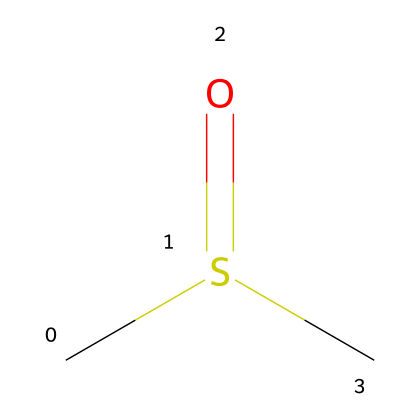What is the name of this chemical? The SMILES representation (CS(=O)C) indicates that the chemical has a sulfur atom and is a sulfoxide. Therefore, the correct name is dimethyl sulfoxide.
Answer: dimethyl sulfoxide How many carbon atoms are in dimethyl sulfoxide (DMSO)? Analyzing the SMILES code, there are two carbon atoms represented by the "C" symbols, which show the methyl groups attached to the sulfur.
Answer: 2 What type of functional group is present in dimethyl sulfoxide? The "=O" part of the structure indicates a carbonyl group bonded to sulfur, classifying it as a sulfoxide functional group.
Answer: sulfoxide What is the total number of atoms in dimethyl sulfoxide? Counting all the atoms in the SMILES notation: 2 carbon, 1 sulfur, 1 oxygen, and 6 hydrogen atoms give a total of 10 atoms.
Answer: 10 What property does the presence of sulfur in DMSO impart? The sulfur atom enhances solvent properties, making DMSO a polar aprotic solvent, which is important in applications like special effects.
Answer: polar aprotic Is dimethyl sulfoxide a solid, liquid, or gas at room temperature? Given that dimethyl sulfoxide is commonly known to be a liquid at room temperature, this can be inferred from its common use as a solvent.
Answer: liquid 